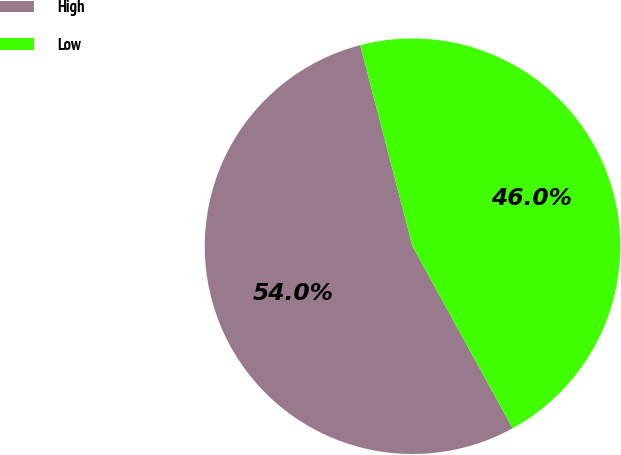<chart> <loc_0><loc_0><loc_500><loc_500><pie_chart><fcel>High<fcel>Low<nl><fcel>53.95%<fcel>46.05%<nl></chart> 